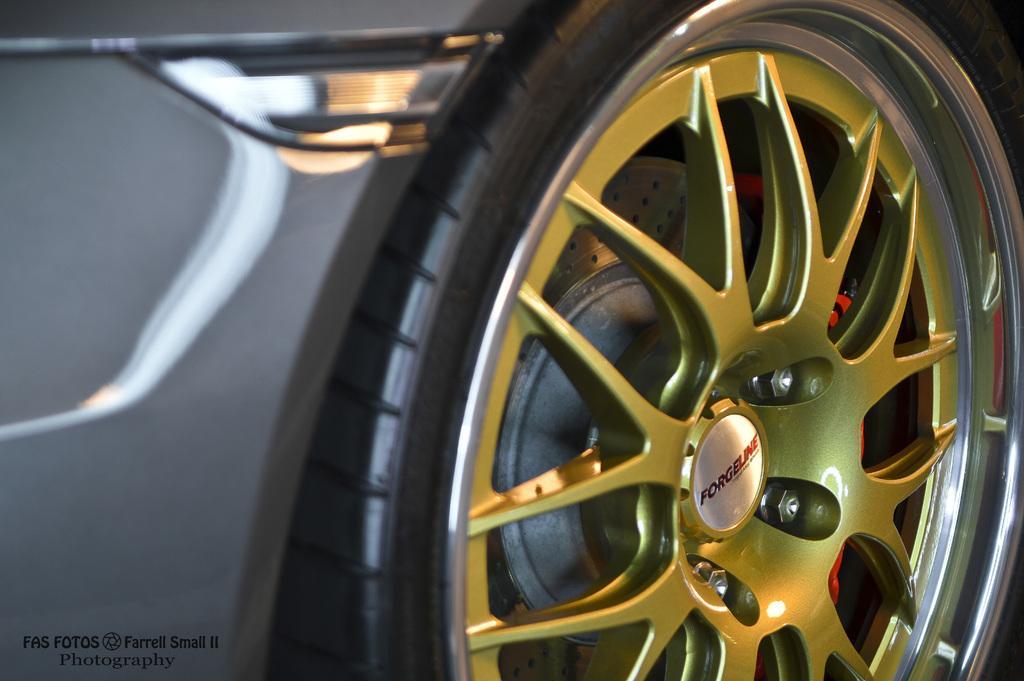How would you summarize this image in a sentence or two? In this image we can see the tire of a vehicle. 